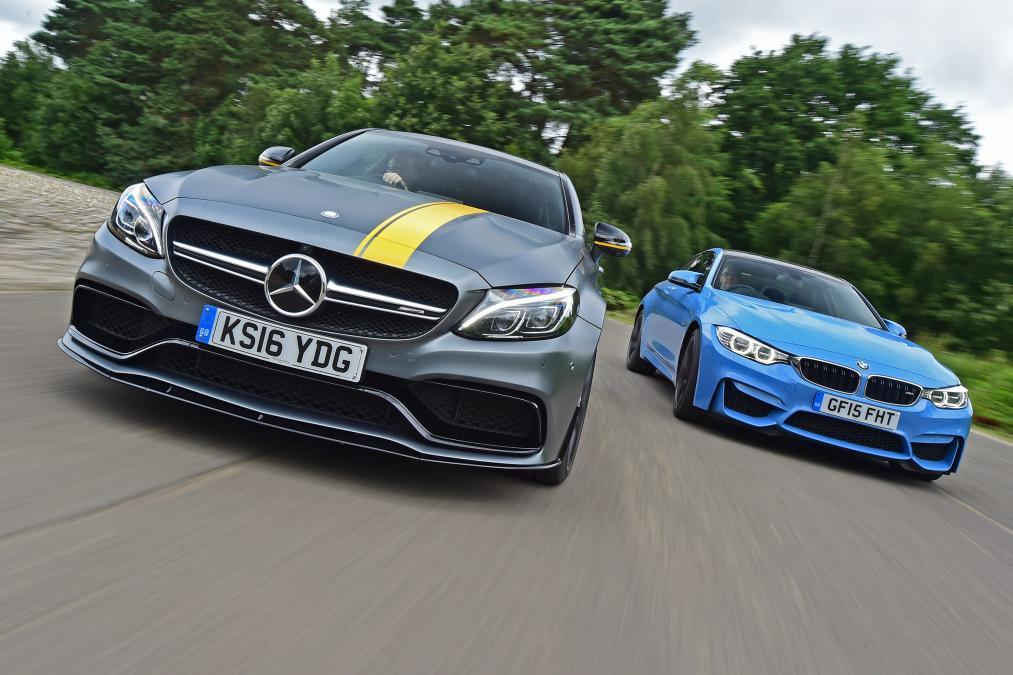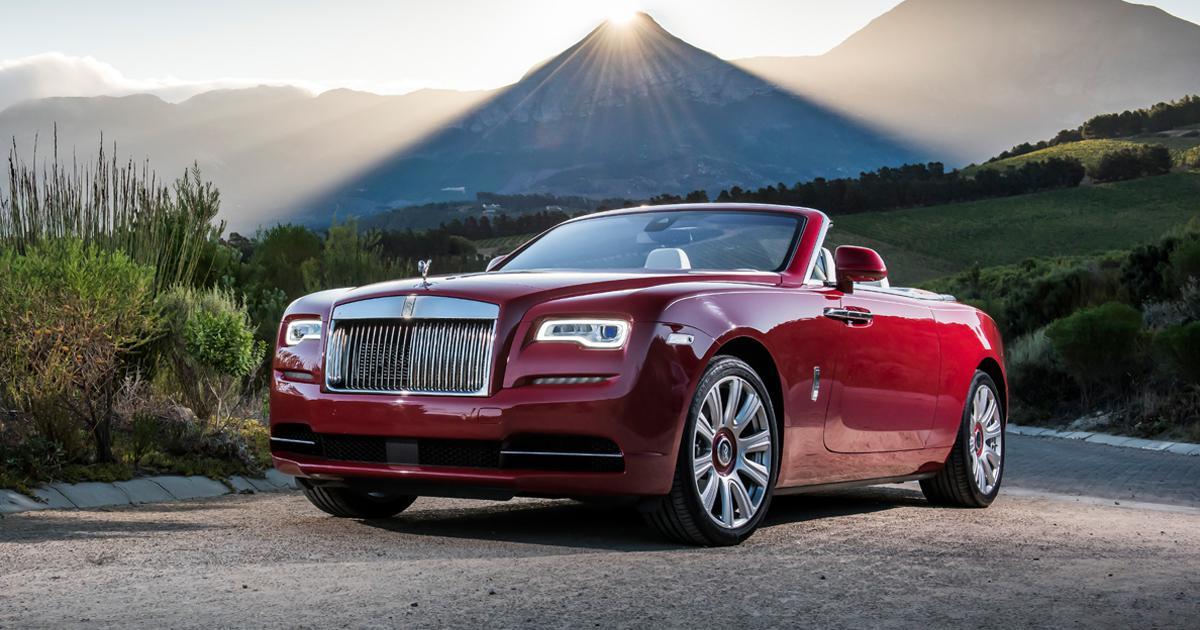The first image is the image on the left, the second image is the image on the right. For the images shown, is this caption "The left image contains two cars including one blue one, and the right image includes a dark red convertible with its top down." true? Answer yes or no. Yes. The first image is the image on the left, the second image is the image on the right. For the images displayed, is the sentence "There are two cars being driven on roads." factually correct? Answer yes or no. Yes. 